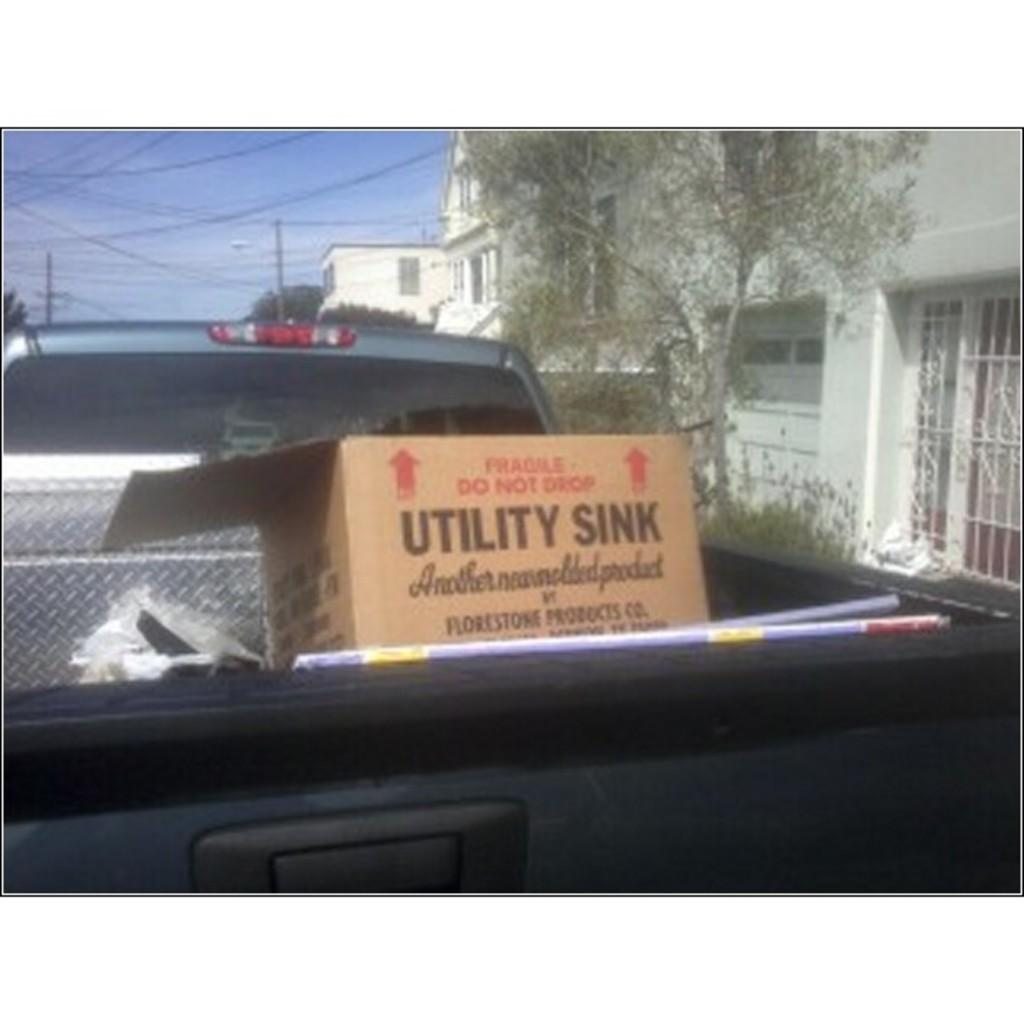What is the main object in the image? There is a cardboard box in the image. What can be found inside the cardboard box? The information provided does not specify what is inside the cardboard box. What can be seen in the background of the image? Buildings, windows, trees, poles, and wires are visible in the background. What is the color of the sky in the image? The sky is blue in color. What type of baseball can be heard in the image? There is no baseball or any sound mentioned in the image, so it cannot be determined if a baseball can be heard. 